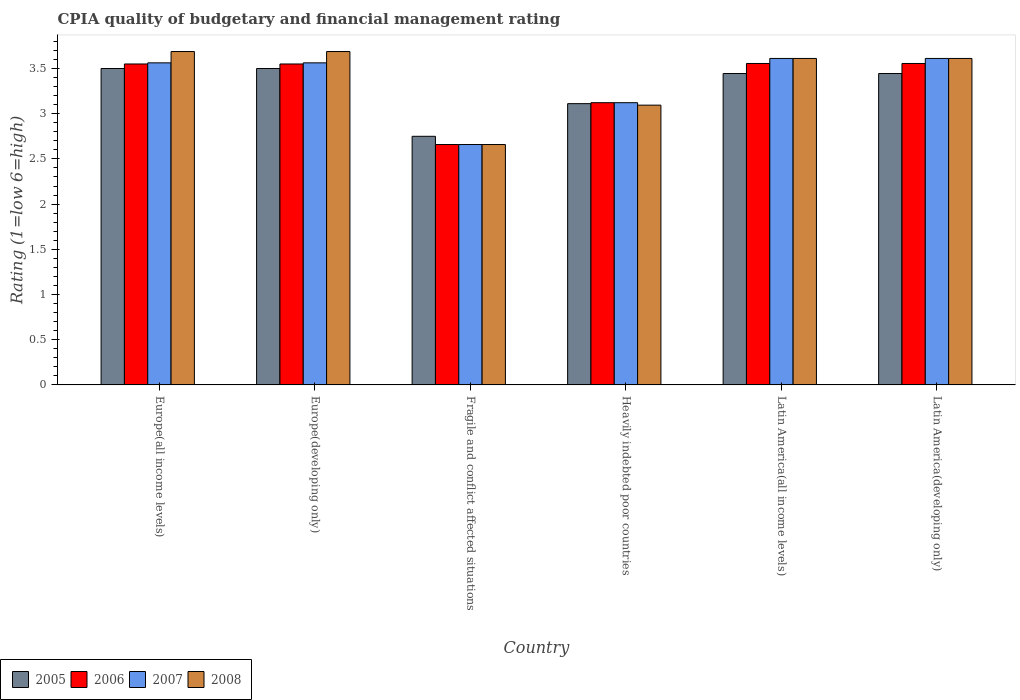Are the number of bars per tick equal to the number of legend labels?
Your answer should be very brief. Yes. Are the number of bars on each tick of the X-axis equal?
Your answer should be very brief. Yes. What is the label of the 5th group of bars from the left?
Your answer should be compact. Latin America(all income levels). What is the CPIA rating in 2006 in Fragile and conflict affected situations?
Your response must be concise. 2.66. Across all countries, what is the maximum CPIA rating in 2006?
Offer a very short reply. 3.56. Across all countries, what is the minimum CPIA rating in 2008?
Your answer should be very brief. 2.66. In which country was the CPIA rating in 2008 maximum?
Your answer should be very brief. Europe(all income levels). In which country was the CPIA rating in 2007 minimum?
Make the answer very short. Fragile and conflict affected situations. What is the total CPIA rating in 2008 in the graph?
Your answer should be very brief. 20.35. What is the difference between the CPIA rating in 2008 in Europe(developing only) and that in Latin America(all income levels)?
Ensure brevity in your answer.  0.08. What is the difference between the CPIA rating in 2008 in Fragile and conflict affected situations and the CPIA rating in 2007 in Heavily indebted poor countries?
Provide a short and direct response. -0.46. What is the average CPIA rating in 2008 per country?
Your response must be concise. 3.39. What is the difference between the CPIA rating of/in 2007 and CPIA rating of/in 2005 in Latin America(all income levels)?
Your answer should be very brief. 0.17. What is the ratio of the CPIA rating in 2005 in Heavily indebted poor countries to that in Latin America(developing only)?
Ensure brevity in your answer.  0.9. What is the difference between the highest and the second highest CPIA rating in 2008?
Provide a short and direct response. -0.08. What is the difference between the highest and the lowest CPIA rating in 2008?
Your response must be concise. 1.03. Is the sum of the CPIA rating in 2005 in Heavily indebted poor countries and Latin America(all income levels) greater than the maximum CPIA rating in 2007 across all countries?
Keep it short and to the point. Yes. What does the 4th bar from the right in Europe(developing only) represents?
Offer a terse response. 2005. Is it the case that in every country, the sum of the CPIA rating in 2008 and CPIA rating in 2007 is greater than the CPIA rating in 2005?
Give a very brief answer. Yes. How many bars are there?
Keep it short and to the point. 24. Does the graph contain any zero values?
Offer a terse response. No. Does the graph contain grids?
Ensure brevity in your answer.  No. How many legend labels are there?
Your answer should be very brief. 4. What is the title of the graph?
Your answer should be compact. CPIA quality of budgetary and financial management rating. What is the label or title of the Y-axis?
Keep it short and to the point. Rating (1=low 6=high). What is the Rating (1=low 6=high) in 2005 in Europe(all income levels)?
Provide a short and direct response. 3.5. What is the Rating (1=low 6=high) in 2006 in Europe(all income levels)?
Provide a succinct answer. 3.55. What is the Rating (1=low 6=high) of 2007 in Europe(all income levels)?
Your answer should be compact. 3.56. What is the Rating (1=low 6=high) of 2008 in Europe(all income levels)?
Keep it short and to the point. 3.69. What is the Rating (1=low 6=high) of 2005 in Europe(developing only)?
Your answer should be very brief. 3.5. What is the Rating (1=low 6=high) of 2006 in Europe(developing only)?
Keep it short and to the point. 3.55. What is the Rating (1=low 6=high) of 2007 in Europe(developing only)?
Offer a very short reply. 3.56. What is the Rating (1=low 6=high) of 2008 in Europe(developing only)?
Keep it short and to the point. 3.69. What is the Rating (1=low 6=high) of 2005 in Fragile and conflict affected situations?
Offer a very short reply. 2.75. What is the Rating (1=low 6=high) in 2006 in Fragile and conflict affected situations?
Ensure brevity in your answer.  2.66. What is the Rating (1=low 6=high) in 2007 in Fragile and conflict affected situations?
Ensure brevity in your answer.  2.66. What is the Rating (1=low 6=high) of 2008 in Fragile and conflict affected situations?
Provide a short and direct response. 2.66. What is the Rating (1=low 6=high) in 2005 in Heavily indebted poor countries?
Offer a terse response. 3.11. What is the Rating (1=low 6=high) in 2006 in Heavily indebted poor countries?
Your answer should be compact. 3.12. What is the Rating (1=low 6=high) of 2007 in Heavily indebted poor countries?
Give a very brief answer. 3.12. What is the Rating (1=low 6=high) of 2008 in Heavily indebted poor countries?
Make the answer very short. 3.09. What is the Rating (1=low 6=high) of 2005 in Latin America(all income levels)?
Ensure brevity in your answer.  3.44. What is the Rating (1=low 6=high) in 2006 in Latin America(all income levels)?
Your answer should be compact. 3.56. What is the Rating (1=low 6=high) of 2007 in Latin America(all income levels)?
Offer a very short reply. 3.61. What is the Rating (1=low 6=high) in 2008 in Latin America(all income levels)?
Keep it short and to the point. 3.61. What is the Rating (1=low 6=high) in 2005 in Latin America(developing only)?
Keep it short and to the point. 3.44. What is the Rating (1=low 6=high) of 2006 in Latin America(developing only)?
Keep it short and to the point. 3.56. What is the Rating (1=low 6=high) in 2007 in Latin America(developing only)?
Provide a short and direct response. 3.61. What is the Rating (1=low 6=high) of 2008 in Latin America(developing only)?
Give a very brief answer. 3.61. Across all countries, what is the maximum Rating (1=low 6=high) of 2005?
Provide a short and direct response. 3.5. Across all countries, what is the maximum Rating (1=low 6=high) in 2006?
Offer a terse response. 3.56. Across all countries, what is the maximum Rating (1=low 6=high) in 2007?
Ensure brevity in your answer.  3.61. Across all countries, what is the maximum Rating (1=low 6=high) in 2008?
Offer a terse response. 3.69. Across all countries, what is the minimum Rating (1=low 6=high) of 2005?
Make the answer very short. 2.75. Across all countries, what is the minimum Rating (1=low 6=high) of 2006?
Provide a succinct answer. 2.66. Across all countries, what is the minimum Rating (1=low 6=high) in 2007?
Offer a very short reply. 2.66. Across all countries, what is the minimum Rating (1=low 6=high) in 2008?
Your answer should be compact. 2.66. What is the total Rating (1=low 6=high) in 2005 in the graph?
Give a very brief answer. 19.75. What is the total Rating (1=low 6=high) of 2006 in the graph?
Offer a terse response. 19.99. What is the total Rating (1=low 6=high) in 2007 in the graph?
Provide a short and direct response. 20.13. What is the total Rating (1=low 6=high) in 2008 in the graph?
Provide a short and direct response. 20.35. What is the difference between the Rating (1=low 6=high) of 2007 in Europe(all income levels) and that in Europe(developing only)?
Your response must be concise. 0. What is the difference between the Rating (1=low 6=high) of 2008 in Europe(all income levels) and that in Europe(developing only)?
Ensure brevity in your answer.  0. What is the difference between the Rating (1=low 6=high) in 2006 in Europe(all income levels) and that in Fragile and conflict affected situations?
Your response must be concise. 0.89. What is the difference between the Rating (1=low 6=high) of 2007 in Europe(all income levels) and that in Fragile and conflict affected situations?
Your answer should be very brief. 0.9. What is the difference between the Rating (1=low 6=high) of 2008 in Europe(all income levels) and that in Fragile and conflict affected situations?
Offer a terse response. 1.03. What is the difference between the Rating (1=low 6=high) in 2005 in Europe(all income levels) and that in Heavily indebted poor countries?
Your answer should be compact. 0.39. What is the difference between the Rating (1=low 6=high) of 2006 in Europe(all income levels) and that in Heavily indebted poor countries?
Your answer should be very brief. 0.43. What is the difference between the Rating (1=low 6=high) in 2007 in Europe(all income levels) and that in Heavily indebted poor countries?
Keep it short and to the point. 0.44. What is the difference between the Rating (1=low 6=high) in 2008 in Europe(all income levels) and that in Heavily indebted poor countries?
Make the answer very short. 0.59. What is the difference between the Rating (1=low 6=high) of 2005 in Europe(all income levels) and that in Latin America(all income levels)?
Provide a short and direct response. 0.06. What is the difference between the Rating (1=low 6=high) in 2006 in Europe(all income levels) and that in Latin America(all income levels)?
Offer a very short reply. -0.01. What is the difference between the Rating (1=low 6=high) in 2007 in Europe(all income levels) and that in Latin America(all income levels)?
Give a very brief answer. -0.05. What is the difference between the Rating (1=low 6=high) in 2008 in Europe(all income levels) and that in Latin America(all income levels)?
Offer a very short reply. 0.08. What is the difference between the Rating (1=low 6=high) of 2005 in Europe(all income levels) and that in Latin America(developing only)?
Your answer should be compact. 0.06. What is the difference between the Rating (1=low 6=high) of 2006 in Europe(all income levels) and that in Latin America(developing only)?
Provide a succinct answer. -0.01. What is the difference between the Rating (1=low 6=high) of 2007 in Europe(all income levels) and that in Latin America(developing only)?
Your answer should be compact. -0.05. What is the difference between the Rating (1=low 6=high) in 2008 in Europe(all income levels) and that in Latin America(developing only)?
Your answer should be very brief. 0.08. What is the difference between the Rating (1=low 6=high) in 2006 in Europe(developing only) and that in Fragile and conflict affected situations?
Offer a terse response. 0.89. What is the difference between the Rating (1=low 6=high) of 2007 in Europe(developing only) and that in Fragile and conflict affected situations?
Ensure brevity in your answer.  0.9. What is the difference between the Rating (1=low 6=high) of 2008 in Europe(developing only) and that in Fragile and conflict affected situations?
Offer a very short reply. 1.03. What is the difference between the Rating (1=low 6=high) of 2005 in Europe(developing only) and that in Heavily indebted poor countries?
Ensure brevity in your answer.  0.39. What is the difference between the Rating (1=low 6=high) of 2006 in Europe(developing only) and that in Heavily indebted poor countries?
Your answer should be very brief. 0.43. What is the difference between the Rating (1=low 6=high) of 2007 in Europe(developing only) and that in Heavily indebted poor countries?
Offer a very short reply. 0.44. What is the difference between the Rating (1=low 6=high) of 2008 in Europe(developing only) and that in Heavily indebted poor countries?
Keep it short and to the point. 0.59. What is the difference between the Rating (1=low 6=high) in 2005 in Europe(developing only) and that in Latin America(all income levels)?
Ensure brevity in your answer.  0.06. What is the difference between the Rating (1=low 6=high) in 2006 in Europe(developing only) and that in Latin America(all income levels)?
Offer a terse response. -0.01. What is the difference between the Rating (1=low 6=high) in 2007 in Europe(developing only) and that in Latin America(all income levels)?
Keep it short and to the point. -0.05. What is the difference between the Rating (1=low 6=high) of 2008 in Europe(developing only) and that in Latin America(all income levels)?
Provide a succinct answer. 0.08. What is the difference between the Rating (1=low 6=high) of 2005 in Europe(developing only) and that in Latin America(developing only)?
Provide a short and direct response. 0.06. What is the difference between the Rating (1=low 6=high) of 2006 in Europe(developing only) and that in Latin America(developing only)?
Make the answer very short. -0.01. What is the difference between the Rating (1=low 6=high) of 2007 in Europe(developing only) and that in Latin America(developing only)?
Your answer should be very brief. -0.05. What is the difference between the Rating (1=low 6=high) in 2008 in Europe(developing only) and that in Latin America(developing only)?
Your answer should be compact. 0.08. What is the difference between the Rating (1=low 6=high) of 2005 in Fragile and conflict affected situations and that in Heavily indebted poor countries?
Offer a terse response. -0.36. What is the difference between the Rating (1=low 6=high) in 2006 in Fragile and conflict affected situations and that in Heavily indebted poor countries?
Keep it short and to the point. -0.46. What is the difference between the Rating (1=low 6=high) in 2007 in Fragile and conflict affected situations and that in Heavily indebted poor countries?
Provide a short and direct response. -0.46. What is the difference between the Rating (1=low 6=high) in 2008 in Fragile and conflict affected situations and that in Heavily indebted poor countries?
Offer a very short reply. -0.44. What is the difference between the Rating (1=low 6=high) in 2005 in Fragile and conflict affected situations and that in Latin America(all income levels)?
Offer a terse response. -0.69. What is the difference between the Rating (1=low 6=high) of 2006 in Fragile and conflict affected situations and that in Latin America(all income levels)?
Your answer should be very brief. -0.9. What is the difference between the Rating (1=low 6=high) of 2007 in Fragile and conflict affected situations and that in Latin America(all income levels)?
Keep it short and to the point. -0.95. What is the difference between the Rating (1=low 6=high) in 2008 in Fragile and conflict affected situations and that in Latin America(all income levels)?
Provide a succinct answer. -0.95. What is the difference between the Rating (1=low 6=high) of 2005 in Fragile and conflict affected situations and that in Latin America(developing only)?
Ensure brevity in your answer.  -0.69. What is the difference between the Rating (1=low 6=high) in 2006 in Fragile and conflict affected situations and that in Latin America(developing only)?
Your answer should be very brief. -0.9. What is the difference between the Rating (1=low 6=high) of 2007 in Fragile and conflict affected situations and that in Latin America(developing only)?
Make the answer very short. -0.95. What is the difference between the Rating (1=low 6=high) in 2008 in Fragile and conflict affected situations and that in Latin America(developing only)?
Your answer should be compact. -0.95. What is the difference between the Rating (1=low 6=high) of 2005 in Heavily indebted poor countries and that in Latin America(all income levels)?
Provide a succinct answer. -0.33. What is the difference between the Rating (1=low 6=high) of 2006 in Heavily indebted poor countries and that in Latin America(all income levels)?
Make the answer very short. -0.43. What is the difference between the Rating (1=low 6=high) of 2007 in Heavily indebted poor countries and that in Latin America(all income levels)?
Your response must be concise. -0.49. What is the difference between the Rating (1=low 6=high) of 2008 in Heavily indebted poor countries and that in Latin America(all income levels)?
Your response must be concise. -0.52. What is the difference between the Rating (1=low 6=high) of 2005 in Heavily indebted poor countries and that in Latin America(developing only)?
Make the answer very short. -0.33. What is the difference between the Rating (1=low 6=high) in 2006 in Heavily indebted poor countries and that in Latin America(developing only)?
Provide a short and direct response. -0.43. What is the difference between the Rating (1=low 6=high) of 2007 in Heavily indebted poor countries and that in Latin America(developing only)?
Your answer should be compact. -0.49. What is the difference between the Rating (1=low 6=high) in 2008 in Heavily indebted poor countries and that in Latin America(developing only)?
Your answer should be very brief. -0.52. What is the difference between the Rating (1=low 6=high) of 2007 in Latin America(all income levels) and that in Latin America(developing only)?
Provide a succinct answer. 0. What is the difference between the Rating (1=low 6=high) of 2005 in Europe(all income levels) and the Rating (1=low 6=high) of 2007 in Europe(developing only)?
Your response must be concise. -0.06. What is the difference between the Rating (1=low 6=high) in 2005 in Europe(all income levels) and the Rating (1=low 6=high) in 2008 in Europe(developing only)?
Your answer should be compact. -0.19. What is the difference between the Rating (1=low 6=high) in 2006 in Europe(all income levels) and the Rating (1=low 6=high) in 2007 in Europe(developing only)?
Your response must be concise. -0.01. What is the difference between the Rating (1=low 6=high) in 2006 in Europe(all income levels) and the Rating (1=low 6=high) in 2008 in Europe(developing only)?
Your response must be concise. -0.14. What is the difference between the Rating (1=low 6=high) in 2007 in Europe(all income levels) and the Rating (1=low 6=high) in 2008 in Europe(developing only)?
Give a very brief answer. -0.12. What is the difference between the Rating (1=low 6=high) of 2005 in Europe(all income levels) and the Rating (1=low 6=high) of 2006 in Fragile and conflict affected situations?
Your answer should be compact. 0.84. What is the difference between the Rating (1=low 6=high) of 2005 in Europe(all income levels) and the Rating (1=low 6=high) of 2007 in Fragile and conflict affected situations?
Your answer should be compact. 0.84. What is the difference between the Rating (1=low 6=high) in 2005 in Europe(all income levels) and the Rating (1=low 6=high) in 2008 in Fragile and conflict affected situations?
Give a very brief answer. 0.84. What is the difference between the Rating (1=low 6=high) in 2006 in Europe(all income levels) and the Rating (1=low 6=high) in 2007 in Fragile and conflict affected situations?
Provide a succinct answer. 0.89. What is the difference between the Rating (1=low 6=high) of 2006 in Europe(all income levels) and the Rating (1=low 6=high) of 2008 in Fragile and conflict affected situations?
Offer a very short reply. 0.89. What is the difference between the Rating (1=low 6=high) of 2007 in Europe(all income levels) and the Rating (1=low 6=high) of 2008 in Fragile and conflict affected situations?
Ensure brevity in your answer.  0.9. What is the difference between the Rating (1=low 6=high) in 2005 in Europe(all income levels) and the Rating (1=low 6=high) in 2006 in Heavily indebted poor countries?
Keep it short and to the point. 0.38. What is the difference between the Rating (1=low 6=high) in 2005 in Europe(all income levels) and the Rating (1=low 6=high) in 2007 in Heavily indebted poor countries?
Give a very brief answer. 0.38. What is the difference between the Rating (1=low 6=high) in 2005 in Europe(all income levels) and the Rating (1=low 6=high) in 2008 in Heavily indebted poor countries?
Offer a very short reply. 0.41. What is the difference between the Rating (1=low 6=high) in 2006 in Europe(all income levels) and the Rating (1=low 6=high) in 2007 in Heavily indebted poor countries?
Provide a short and direct response. 0.43. What is the difference between the Rating (1=low 6=high) of 2006 in Europe(all income levels) and the Rating (1=low 6=high) of 2008 in Heavily indebted poor countries?
Offer a terse response. 0.46. What is the difference between the Rating (1=low 6=high) in 2007 in Europe(all income levels) and the Rating (1=low 6=high) in 2008 in Heavily indebted poor countries?
Provide a succinct answer. 0.47. What is the difference between the Rating (1=low 6=high) of 2005 in Europe(all income levels) and the Rating (1=low 6=high) of 2006 in Latin America(all income levels)?
Provide a short and direct response. -0.06. What is the difference between the Rating (1=low 6=high) in 2005 in Europe(all income levels) and the Rating (1=low 6=high) in 2007 in Latin America(all income levels)?
Provide a succinct answer. -0.11. What is the difference between the Rating (1=low 6=high) in 2005 in Europe(all income levels) and the Rating (1=low 6=high) in 2008 in Latin America(all income levels)?
Your answer should be very brief. -0.11. What is the difference between the Rating (1=low 6=high) in 2006 in Europe(all income levels) and the Rating (1=low 6=high) in 2007 in Latin America(all income levels)?
Offer a very short reply. -0.06. What is the difference between the Rating (1=low 6=high) of 2006 in Europe(all income levels) and the Rating (1=low 6=high) of 2008 in Latin America(all income levels)?
Make the answer very short. -0.06. What is the difference between the Rating (1=low 6=high) of 2007 in Europe(all income levels) and the Rating (1=low 6=high) of 2008 in Latin America(all income levels)?
Ensure brevity in your answer.  -0.05. What is the difference between the Rating (1=low 6=high) in 2005 in Europe(all income levels) and the Rating (1=low 6=high) in 2006 in Latin America(developing only)?
Offer a very short reply. -0.06. What is the difference between the Rating (1=low 6=high) in 2005 in Europe(all income levels) and the Rating (1=low 6=high) in 2007 in Latin America(developing only)?
Keep it short and to the point. -0.11. What is the difference between the Rating (1=low 6=high) in 2005 in Europe(all income levels) and the Rating (1=low 6=high) in 2008 in Latin America(developing only)?
Keep it short and to the point. -0.11. What is the difference between the Rating (1=low 6=high) of 2006 in Europe(all income levels) and the Rating (1=low 6=high) of 2007 in Latin America(developing only)?
Your response must be concise. -0.06. What is the difference between the Rating (1=low 6=high) of 2006 in Europe(all income levels) and the Rating (1=low 6=high) of 2008 in Latin America(developing only)?
Ensure brevity in your answer.  -0.06. What is the difference between the Rating (1=low 6=high) in 2007 in Europe(all income levels) and the Rating (1=low 6=high) in 2008 in Latin America(developing only)?
Ensure brevity in your answer.  -0.05. What is the difference between the Rating (1=low 6=high) in 2005 in Europe(developing only) and the Rating (1=low 6=high) in 2006 in Fragile and conflict affected situations?
Your answer should be very brief. 0.84. What is the difference between the Rating (1=low 6=high) in 2005 in Europe(developing only) and the Rating (1=low 6=high) in 2007 in Fragile and conflict affected situations?
Give a very brief answer. 0.84. What is the difference between the Rating (1=low 6=high) of 2005 in Europe(developing only) and the Rating (1=low 6=high) of 2008 in Fragile and conflict affected situations?
Your response must be concise. 0.84. What is the difference between the Rating (1=low 6=high) in 2006 in Europe(developing only) and the Rating (1=low 6=high) in 2007 in Fragile and conflict affected situations?
Keep it short and to the point. 0.89. What is the difference between the Rating (1=low 6=high) in 2006 in Europe(developing only) and the Rating (1=low 6=high) in 2008 in Fragile and conflict affected situations?
Your answer should be very brief. 0.89. What is the difference between the Rating (1=low 6=high) of 2007 in Europe(developing only) and the Rating (1=low 6=high) of 2008 in Fragile and conflict affected situations?
Your answer should be very brief. 0.9. What is the difference between the Rating (1=low 6=high) of 2005 in Europe(developing only) and the Rating (1=low 6=high) of 2006 in Heavily indebted poor countries?
Your response must be concise. 0.38. What is the difference between the Rating (1=low 6=high) of 2005 in Europe(developing only) and the Rating (1=low 6=high) of 2007 in Heavily indebted poor countries?
Offer a very short reply. 0.38. What is the difference between the Rating (1=low 6=high) of 2005 in Europe(developing only) and the Rating (1=low 6=high) of 2008 in Heavily indebted poor countries?
Your answer should be compact. 0.41. What is the difference between the Rating (1=low 6=high) of 2006 in Europe(developing only) and the Rating (1=low 6=high) of 2007 in Heavily indebted poor countries?
Your response must be concise. 0.43. What is the difference between the Rating (1=low 6=high) in 2006 in Europe(developing only) and the Rating (1=low 6=high) in 2008 in Heavily indebted poor countries?
Your answer should be compact. 0.46. What is the difference between the Rating (1=low 6=high) in 2007 in Europe(developing only) and the Rating (1=low 6=high) in 2008 in Heavily indebted poor countries?
Ensure brevity in your answer.  0.47. What is the difference between the Rating (1=low 6=high) of 2005 in Europe(developing only) and the Rating (1=low 6=high) of 2006 in Latin America(all income levels)?
Your answer should be compact. -0.06. What is the difference between the Rating (1=low 6=high) of 2005 in Europe(developing only) and the Rating (1=low 6=high) of 2007 in Latin America(all income levels)?
Your answer should be very brief. -0.11. What is the difference between the Rating (1=low 6=high) in 2005 in Europe(developing only) and the Rating (1=low 6=high) in 2008 in Latin America(all income levels)?
Ensure brevity in your answer.  -0.11. What is the difference between the Rating (1=low 6=high) of 2006 in Europe(developing only) and the Rating (1=low 6=high) of 2007 in Latin America(all income levels)?
Give a very brief answer. -0.06. What is the difference between the Rating (1=low 6=high) in 2006 in Europe(developing only) and the Rating (1=low 6=high) in 2008 in Latin America(all income levels)?
Your response must be concise. -0.06. What is the difference between the Rating (1=low 6=high) of 2007 in Europe(developing only) and the Rating (1=low 6=high) of 2008 in Latin America(all income levels)?
Ensure brevity in your answer.  -0.05. What is the difference between the Rating (1=low 6=high) in 2005 in Europe(developing only) and the Rating (1=low 6=high) in 2006 in Latin America(developing only)?
Offer a very short reply. -0.06. What is the difference between the Rating (1=low 6=high) of 2005 in Europe(developing only) and the Rating (1=low 6=high) of 2007 in Latin America(developing only)?
Your answer should be very brief. -0.11. What is the difference between the Rating (1=low 6=high) in 2005 in Europe(developing only) and the Rating (1=low 6=high) in 2008 in Latin America(developing only)?
Your answer should be compact. -0.11. What is the difference between the Rating (1=low 6=high) in 2006 in Europe(developing only) and the Rating (1=low 6=high) in 2007 in Latin America(developing only)?
Your answer should be very brief. -0.06. What is the difference between the Rating (1=low 6=high) of 2006 in Europe(developing only) and the Rating (1=low 6=high) of 2008 in Latin America(developing only)?
Provide a short and direct response. -0.06. What is the difference between the Rating (1=low 6=high) in 2007 in Europe(developing only) and the Rating (1=low 6=high) in 2008 in Latin America(developing only)?
Provide a short and direct response. -0.05. What is the difference between the Rating (1=low 6=high) in 2005 in Fragile and conflict affected situations and the Rating (1=low 6=high) in 2006 in Heavily indebted poor countries?
Ensure brevity in your answer.  -0.37. What is the difference between the Rating (1=low 6=high) of 2005 in Fragile and conflict affected situations and the Rating (1=low 6=high) of 2007 in Heavily indebted poor countries?
Your answer should be compact. -0.37. What is the difference between the Rating (1=low 6=high) of 2005 in Fragile and conflict affected situations and the Rating (1=low 6=high) of 2008 in Heavily indebted poor countries?
Give a very brief answer. -0.34. What is the difference between the Rating (1=low 6=high) of 2006 in Fragile and conflict affected situations and the Rating (1=low 6=high) of 2007 in Heavily indebted poor countries?
Your answer should be very brief. -0.46. What is the difference between the Rating (1=low 6=high) in 2006 in Fragile and conflict affected situations and the Rating (1=low 6=high) in 2008 in Heavily indebted poor countries?
Your answer should be compact. -0.44. What is the difference between the Rating (1=low 6=high) of 2007 in Fragile and conflict affected situations and the Rating (1=low 6=high) of 2008 in Heavily indebted poor countries?
Provide a succinct answer. -0.44. What is the difference between the Rating (1=low 6=high) in 2005 in Fragile and conflict affected situations and the Rating (1=low 6=high) in 2006 in Latin America(all income levels)?
Offer a very short reply. -0.81. What is the difference between the Rating (1=low 6=high) in 2005 in Fragile and conflict affected situations and the Rating (1=low 6=high) in 2007 in Latin America(all income levels)?
Your answer should be compact. -0.86. What is the difference between the Rating (1=low 6=high) in 2005 in Fragile and conflict affected situations and the Rating (1=low 6=high) in 2008 in Latin America(all income levels)?
Your answer should be very brief. -0.86. What is the difference between the Rating (1=low 6=high) in 2006 in Fragile and conflict affected situations and the Rating (1=low 6=high) in 2007 in Latin America(all income levels)?
Your answer should be very brief. -0.95. What is the difference between the Rating (1=low 6=high) in 2006 in Fragile and conflict affected situations and the Rating (1=low 6=high) in 2008 in Latin America(all income levels)?
Make the answer very short. -0.95. What is the difference between the Rating (1=low 6=high) in 2007 in Fragile and conflict affected situations and the Rating (1=low 6=high) in 2008 in Latin America(all income levels)?
Give a very brief answer. -0.95. What is the difference between the Rating (1=low 6=high) of 2005 in Fragile and conflict affected situations and the Rating (1=low 6=high) of 2006 in Latin America(developing only)?
Your response must be concise. -0.81. What is the difference between the Rating (1=low 6=high) in 2005 in Fragile and conflict affected situations and the Rating (1=low 6=high) in 2007 in Latin America(developing only)?
Ensure brevity in your answer.  -0.86. What is the difference between the Rating (1=low 6=high) of 2005 in Fragile and conflict affected situations and the Rating (1=low 6=high) of 2008 in Latin America(developing only)?
Give a very brief answer. -0.86. What is the difference between the Rating (1=low 6=high) of 2006 in Fragile and conflict affected situations and the Rating (1=low 6=high) of 2007 in Latin America(developing only)?
Your response must be concise. -0.95. What is the difference between the Rating (1=low 6=high) of 2006 in Fragile and conflict affected situations and the Rating (1=low 6=high) of 2008 in Latin America(developing only)?
Give a very brief answer. -0.95. What is the difference between the Rating (1=low 6=high) of 2007 in Fragile and conflict affected situations and the Rating (1=low 6=high) of 2008 in Latin America(developing only)?
Give a very brief answer. -0.95. What is the difference between the Rating (1=low 6=high) of 2005 in Heavily indebted poor countries and the Rating (1=low 6=high) of 2006 in Latin America(all income levels)?
Provide a succinct answer. -0.44. What is the difference between the Rating (1=low 6=high) of 2006 in Heavily indebted poor countries and the Rating (1=low 6=high) of 2007 in Latin America(all income levels)?
Provide a succinct answer. -0.49. What is the difference between the Rating (1=low 6=high) in 2006 in Heavily indebted poor countries and the Rating (1=low 6=high) in 2008 in Latin America(all income levels)?
Give a very brief answer. -0.49. What is the difference between the Rating (1=low 6=high) of 2007 in Heavily indebted poor countries and the Rating (1=low 6=high) of 2008 in Latin America(all income levels)?
Ensure brevity in your answer.  -0.49. What is the difference between the Rating (1=low 6=high) of 2005 in Heavily indebted poor countries and the Rating (1=low 6=high) of 2006 in Latin America(developing only)?
Provide a short and direct response. -0.44. What is the difference between the Rating (1=low 6=high) of 2005 in Heavily indebted poor countries and the Rating (1=low 6=high) of 2007 in Latin America(developing only)?
Your answer should be very brief. -0.5. What is the difference between the Rating (1=low 6=high) in 2005 in Heavily indebted poor countries and the Rating (1=low 6=high) in 2008 in Latin America(developing only)?
Give a very brief answer. -0.5. What is the difference between the Rating (1=low 6=high) of 2006 in Heavily indebted poor countries and the Rating (1=low 6=high) of 2007 in Latin America(developing only)?
Your response must be concise. -0.49. What is the difference between the Rating (1=low 6=high) of 2006 in Heavily indebted poor countries and the Rating (1=low 6=high) of 2008 in Latin America(developing only)?
Make the answer very short. -0.49. What is the difference between the Rating (1=low 6=high) of 2007 in Heavily indebted poor countries and the Rating (1=low 6=high) of 2008 in Latin America(developing only)?
Your response must be concise. -0.49. What is the difference between the Rating (1=low 6=high) in 2005 in Latin America(all income levels) and the Rating (1=low 6=high) in 2006 in Latin America(developing only)?
Offer a very short reply. -0.11. What is the difference between the Rating (1=low 6=high) in 2006 in Latin America(all income levels) and the Rating (1=low 6=high) in 2007 in Latin America(developing only)?
Offer a very short reply. -0.06. What is the difference between the Rating (1=low 6=high) in 2006 in Latin America(all income levels) and the Rating (1=low 6=high) in 2008 in Latin America(developing only)?
Your answer should be compact. -0.06. What is the difference between the Rating (1=low 6=high) in 2007 in Latin America(all income levels) and the Rating (1=low 6=high) in 2008 in Latin America(developing only)?
Give a very brief answer. 0. What is the average Rating (1=low 6=high) of 2005 per country?
Your answer should be compact. 3.29. What is the average Rating (1=low 6=high) of 2006 per country?
Your response must be concise. 3.33. What is the average Rating (1=low 6=high) of 2007 per country?
Provide a succinct answer. 3.35. What is the average Rating (1=low 6=high) in 2008 per country?
Your answer should be very brief. 3.39. What is the difference between the Rating (1=low 6=high) of 2005 and Rating (1=low 6=high) of 2006 in Europe(all income levels)?
Your answer should be very brief. -0.05. What is the difference between the Rating (1=low 6=high) in 2005 and Rating (1=low 6=high) in 2007 in Europe(all income levels)?
Your answer should be compact. -0.06. What is the difference between the Rating (1=low 6=high) of 2005 and Rating (1=low 6=high) of 2008 in Europe(all income levels)?
Ensure brevity in your answer.  -0.19. What is the difference between the Rating (1=low 6=high) in 2006 and Rating (1=low 6=high) in 2007 in Europe(all income levels)?
Provide a succinct answer. -0.01. What is the difference between the Rating (1=low 6=high) of 2006 and Rating (1=low 6=high) of 2008 in Europe(all income levels)?
Your answer should be very brief. -0.14. What is the difference between the Rating (1=low 6=high) in 2007 and Rating (1=low 6=high) in 2008 in Europe(all income levels)?
Your response must be concise. -0.12. What is the difference between the Rating (1=low 6=high) in 2005 and Rating (1=low 6=high) in 2007 in Europe(developing only)?
Provide a short and direct response. -0.06. What is the difference between the Rating (1=low 6=high) of 2005 and Rating (1=low 6=high) of 2008 in Europe(developing only)?
Offer a very short reply. -0.19. What is the difference between the Rating (1=low 6=high) in 2006 and Rating (1=low 6=high) in 2007 in Europe(developing only)?
Your answer should be compact. -0.01. What is the difference between the Rating (1=low 6=high) of 2006 and Rating (1=low 6=high) of 2008 in Europe(developing only)?
Keep it short and to the point. -0.14. What is the difference between the Rating (1=low 6=high) in 2007 and Rating (1=low 6=high) in 2008 in Europe(developing only)?
Keep it short and to the point. -0.12. What is the difference between the Rating (1=low 6=high) in 2005 and Rating (1=low 6=high) in 2006 in Fragile and conflict affected situations?
Your answer should be compact. 0.09. What is the difference between the Rating (1=low 6=high) in 2005 and Rating (1=low 6=high) in 2007 in Fragile and conflict affected situations?
Keep it short and to the point. 0.09. What is the difference between the Rating (1=low 6=high) in 2005 and Rating (1=low 6=high) in 2008 in Fragile and conflict affected situations?
Keep it short and to the point. 0.09. What is the difference between the Rating (1=low 6=high) in 2006 and Rating (1=low 6=high) in 2007 in Fragile and conflict affected situations?
Your response must be concise. 0. What is the difference between the Rating (1=low 6=high) of 2006 and Rating (1=low 6=high) of 2008 in Fragile and conflict affected situations?
Keep it short and to the point. 0. What is the difference between the Rating (1=low 6=high) in 2005 and Rating (1=low 6=high) in 2006 in Heavily indebted poor countries?
Offer a terse response. -0.01. What is the difference between the Rating (1=low 6=high) of 2005 and Rating (1=low 6=high) of 2007 in Heavily indebted poor countries?
Make the answer very short. -0.01. What is the difference between the Rating (1=low 6=high) in 2005 and Rating (1=low 6=high) in 2008 in Heavily indebted poor countries?
Offer a terse response. 0.02. What is the difference between the Rating (1=low 6=high) in 2006 and Rating (1=low 6=high) in 2007 in Heavily indebted poor countries?
Keep it short and to the point. 0. What is the difference between the Rating (1=low 6=high) of 2006 and Rating (1=low 6=high) of 2008 in Heavily indebted poor countries?
Offer a very short reply. 0.03. What is the difference between the Rating (1=low 6=high) in 2007 and Rating (1=low 6=high) in 2008 in Heavily indebted poor countries?
Make the answer very short. 0.03. What is the difference between the Rating (1=low 6=high) in 2005 and Rating (1=low 6=high) in 2006 in Latin America(all income levels)?
Your answer should be compact. -0.11. What is the difference between the Rating (1=low 6=high) of 2005 and Rating (1=low 6=high) of 2008 in Latin America(all income levels)?
Your response must be concise. -0.17. What is the difference between the Rating (1=low 6=high) in 2006 and Rating (1=low 6=high) in 2007 in Latin America(all income levels)?
Keep it short and to the point. -0.06. What is the difference between the Rating (1=low 6=high) in 2006 and Rating (1=low 6=high) in 2008 in Latin America(all income levels)?
Provide a succinct answer. -0.06. What is the difference between the Rating (1=low 6=high) of 2007 and Rating (1=low 6=high) of 2008 in Latin America(all income levels)?
Your answer should be compact. 0. What is the difference between the Rating (1=low 6=high) in 2005 and Rating (1=low 6=high) in 2006 in Latin America(developing only)?
Offer a very short reply. -0.11. What is the difference between the Rating (1=low 6=high) of 2005 and Rating (1=low 6=high) of 2007 in Latin America(developing only)?
Offer a very short reply. -0.17. What is the difference between the Rating (1=low 6=high) in 2006 and Rating (1=low 6=high) in 2007 in Latin America(developing only)?
Offer a very short reply. -0.06. What is the difference between the Rating (1=low 6=high) of 2006 and Rating (1=low 6=high) of 2008 in Latin America(developing only)?
Offer a terse response. -0.06. What is the ratio of the Rating (1=low 6=high) in 2005 in Europe(all income levels) to that in Europe(developing only)?
Your answer should be compact. 1. What is the ratio of the Rating (1=low 6=high) in 2006 in Europe(all income levels) to that in Europe(developing only)?
Your answer should be very brief. 1. What is the ratio of the Rating (1=low 6=high) of 2005 in Europe(all income levels) to that in Fragile and conflict affected situations?
Give a very brief answer. 1.27. What is the ratio of the Rating (1=low 6=high) of 2006 in Europe(all income levels) to that in Fragile and conflict affected situations?
Provide a short and direct response. 1.33. What is the ratio of the Rating (1=low 6=high) of 2007 in Europe(all income levels) to that in Fragile and conflict affected situations?
Your answer should be very brief. 1.34. What is the ratio of the Rating (1=low 6=high) in 2008 in Europe(all income levels) to that in Fragile and conflict affected situations?
Make the answer very short. 1.39. What is the ratio of the Rating (1=low 6=high) in 2005 in Europe(all income levels) to that in Heavily indebted poor countries?
Your answer should be compact. 1.12. What is the ratio of the Rating (1=low 6=high) of 2006 in Europe(all income levels) to that in Heavily indebted poor countries?
Ensure brevity in your answer.  1.14. What is the ratio of the Rating (1=low 6=high) of 2007 in Europe(all income levels) to that in Heavily indebted poor countries?
Provide a succinct answer. 1.14. What is the ratio of the Rating (1=low 6=high) of 2008 in Europe(all income levels) to that in Heavily indebted poor countries?
Make the answer very short. 1.19. What is the ratio of the Rating (1=low 6=high) in 2005 in Europe(all income levels) to that in Latin America(all income levels)?
Ensure brevity in your answer.  1.02. What is the ratio of the Rating (1=low 6=high) in 2007 in Europe(all income levels) to that in Latin America(all income levels)?
Provide a short and direct response. 0.99. What is the ratio of the Rating (1=low 6=high) of 2008 in Europe(all income levels) to that in Latin America(all income levels)?
Provide a succinct answer. 1.02. What is the ratio of the Rating (1=low 6=high) of 2005 in Europe(all income levels) to that in Latin America(developing only)?
Your answer should be very brief. 1.02. What is the ratio of the Rating (1=low 6=high) of 2007 in Europe(all income levels) to that in Latin America(developing only)?
Provide a succinct answer. 0.99. What is the ratio of the Rating (1=low 6=high) in 2008 in Europe(all income levels) to that in Latin America(developing only)?
Provide a short and direct response. 1.02. What is the ratio of the Rating (1=low 6=high) in 2005 in Europe(developing only) to that in Fragile and conflict affected situations?
Your answer should be very brief. 1.27. What is the ratio of the Rating (1=low 6=high) in 2006 in Europe(developing only) to that in Fragile and conflict affected situations?
Your answer should be very brief. 1.33. What is the ratio of the Rating (1=low 6=high) of 2007 in Europe(developing only) to that in Fragile and conflict affected situations?
Give a very brief answer. 1.34. What is the ratio of the Rating (1=low 6=high) of 2008 in Europe(developing only) to that in Fragile and conflict affected situations?
Provide a succinct answer. 1.39. What is the ratio of the Rating (1=low 6=high) in 2006 in Europe(developing only) to that in Heavily indebted poor countries?
Provide a succinct answer. 1.14. What is the ratio of the Rating (1=low 6=high) of 2007 in Europe(developing only) to that in Heavily indebted poor countries?
Offer a very short reply. 1.14. What is the ratio of the Rating (1=low 6=high) of 2008 in Europe(developing only) to that in Heavily indebted poor countries?
Offer a terse response. 1.19. What is the ratio of the Rating (1=low 6=high) in 2005 in Europe(developing only) to that in Latin America(all income levels)?
Offer a very short reply. 1.02. What is the ratio of the Rating (1=low 6=high) of 2006 in Europe(developing only) to that in Latin America(all income levels)?
Give a very brief answer. 1. What is the ratio of the Rating (1=low 6=high) of 2007 in Europe(developing only) to that in Latin America(all income levels)?
Your response must be concise. 0.99. What is the ratio of the Rating (1=low 6=high) in 2008 in Europe(developing only) to that in Latin America(all income levels)?
Give a very brief answer. 1.02. What is the ratio of the Rating (1=low 6=high) in 2005 in Europe(developing only) to that in Latin America(developing only)?
Provide a short and direct response. 1.02. What is the ratio of the Rating (1=low 6=high) of 2006 in Europe(developing only) to that in Latin America(developing only)?
Your response must be concise. 1. What is the ratio of the Rating (1=low 6=high) in 2007 in Europe(developing only) to that in Latin America(developing only)?
Your answer should be compact. 0.99. What is the ratio of the Rating (1=low 6=high) in 2008 in Europe(developing only) to that in Latin America(developing only)?
Ensure brevity in your answer.  1.02. What is the ratio of the Rating (1=low 6=high) in 2005 in Fragile and conflict affected situations to that in Heavily indebted poor countries?
Keep it short and to the point. 0.88. What is the ratio of the Rating (1=low 6=high) in 2006 in Fragile and conflict affected situations to that in Heavily indebted poor countries?
Your answer should be very brief. 0.85. What is the ratio of the Rating (1=low 6=high) in 2007 in Fragile and conflict affected situations to that in Heavily indebted poor countries?
Your response must be concise. 0.85. What is the ratio of the Rating (1=low 6=high) in 2008 in Fragile and conflict affected situations to that in Heavily indebted poor countries?
Keep it short and to the point. 0.86. What is the ratio of the Rating (1=low 6=high) in 2005 in Fragile and conflict affected situations to that in Latin America(all income levels)?
Provide a short and direct response. 0.8. What is the ratio of the Rating (1=low 6=high) of 2006 in Fragile and conflict affected situations to that in Latin America(all income levels)?
Make the answer very short. 0.75. What is the ratio of the Rating (1=low 6=high) in 2007 in Fragile and conflict affected situations to that in Latin America(all income levels)?
Your answer should be compact. 0.74. What is the ratio of the Rating (1=low 6=high) of 2008 in Fragile and conflict affected situations to that in Latin America(all income levels)?
Offer a terse response. 0.74. What is the ratio of the Rating (1=low 6=high) in 2005 in Fragile and conflict affected situations to that in Latin America(developing only)?
Make the answer very short. 0.8. What is the ratio of the Rating (1=low 6=high) of 2006 in Fragile and conflict affected situations to that in Latin America(developing only)?
Give a very brief answer. 0.75. What is the ratio of the Rating (1=low 6=high) in 2007 in Fragile and conflict affected situations to that in Latin America(developing only)?
Keep it short and to the point. 0.74. What is the ratio of the Rating (1=low 6=high) in 2008 in Fragile and conflict affected situations to that in Latin America(developing only)?
Your answer should be very brief. 0.74. What is the ratio of the Rating (1=low 6=high) in 2005 in Heavily indebted poor countries to that in Latin America(all income levels)?
Your answer should be very brief. 0.9. What is the ratio of the Rating (1=low 6=high) in 2006 in Heavily indebted poor countries to that in Latin America(all income levels)?
Your answer should be very brief. 0.88. What is the ratio of the Rating (1=low 6=high) of 2007 in Heavily indebted poor countries to that in Latin America(all income levels)?
Your response must be concise. 0.86. What is the ratio of the Rating (1=low 6=high) in 2008 in Heavily indebted poor countries to that in Latin America(all income levels)?
Your response must be concise. 0.86. What is the ratio of the Rating (1=low 6=high) in 2005 in Heavily indebted poor countries to that in Latin America(developing only)?
Ensure brevity in your answer.  0.9. What is the ratio of the Rating (1=low 6=high) of 2006 in Heavily indebted poor countries to that in Latin America(developing only)?
Provide a short and direct response. 0.88. What is the ratio of the Rating (1=low 6=high) in 2007 in Heavily indebted poor countries to that in Latin America(developing only)?
Your response must be concise. 0.86. What is the ratio of the Rating (1=low 6=high) of 2008 in Heavily indebted poor countries to that in Latin America(developing only)?
Provide a succinct answer. 0.86. What is the ratio of the Rating (1=low 6=high) in 2006 in Latin America(all income levels) to that in Latin America(developing only)?
Your response must be concise. 1. What is the difference between the highest and the second highest Rating (1=low 6=high) of 2006?
Offer a very short reply. 0. What is the difference between the highest and the lowest Rating (1=low 6=high) in 2006?
Offer a very short reply. 0.9. What is the difference between the highest and the lowest Rating (1=low 6=high) in 2007?
Your answer should be very brief. 0.95. What is the difference between the highest and the lowest Rating (1=low 6=high) in 2008?
Keep it short and to the point. 1.03. 